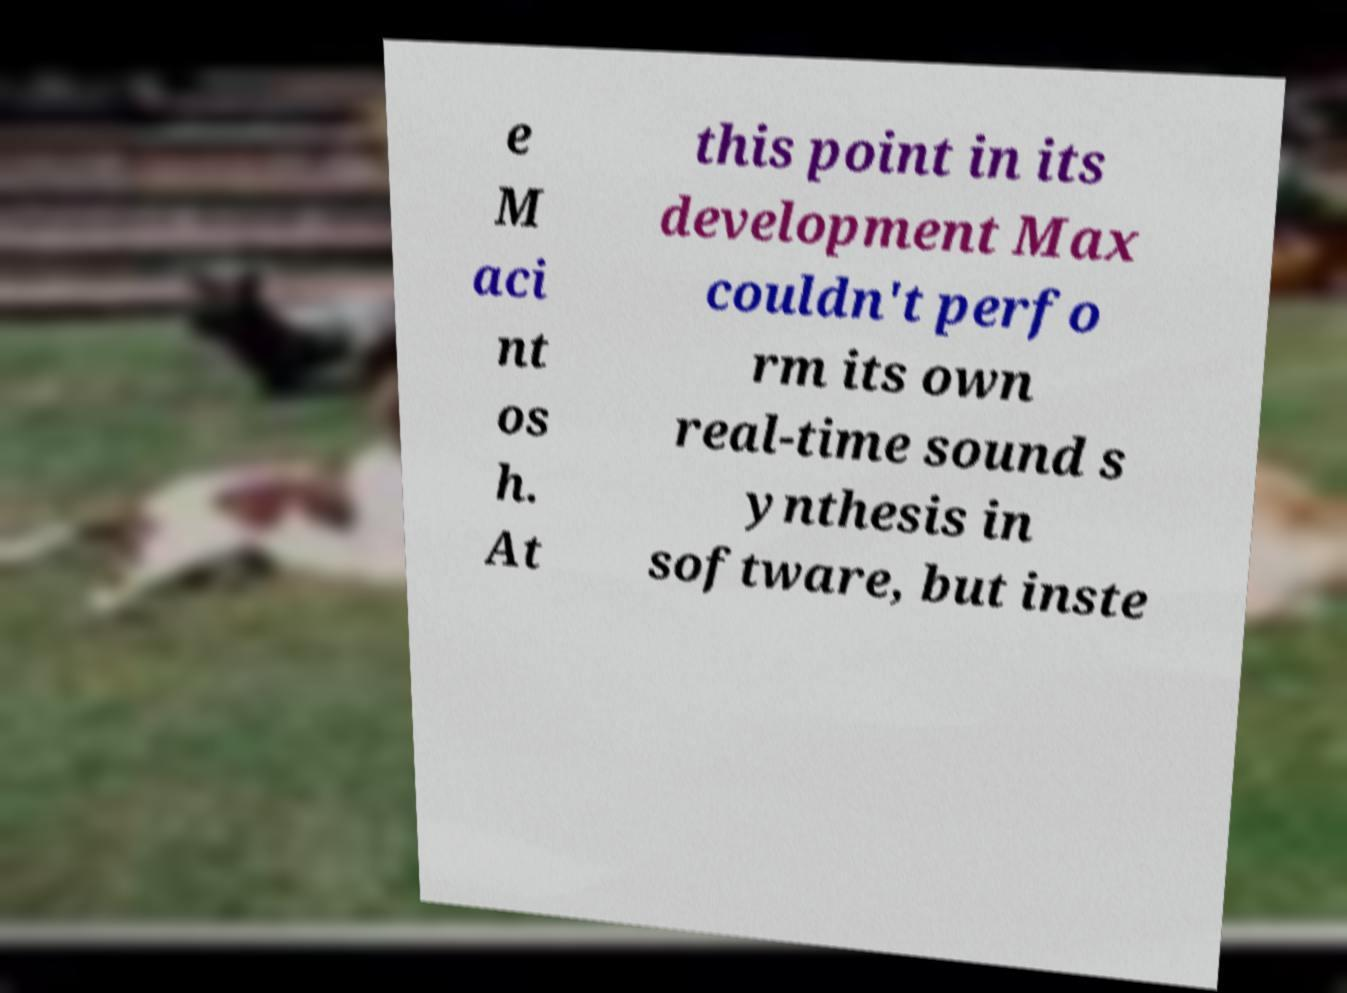Please identify and transcribe the text found in this image. e M aci nt os h. At this point in its development Max couldn't perfo rm its own real-time sound s ynthesis in software, but inste 